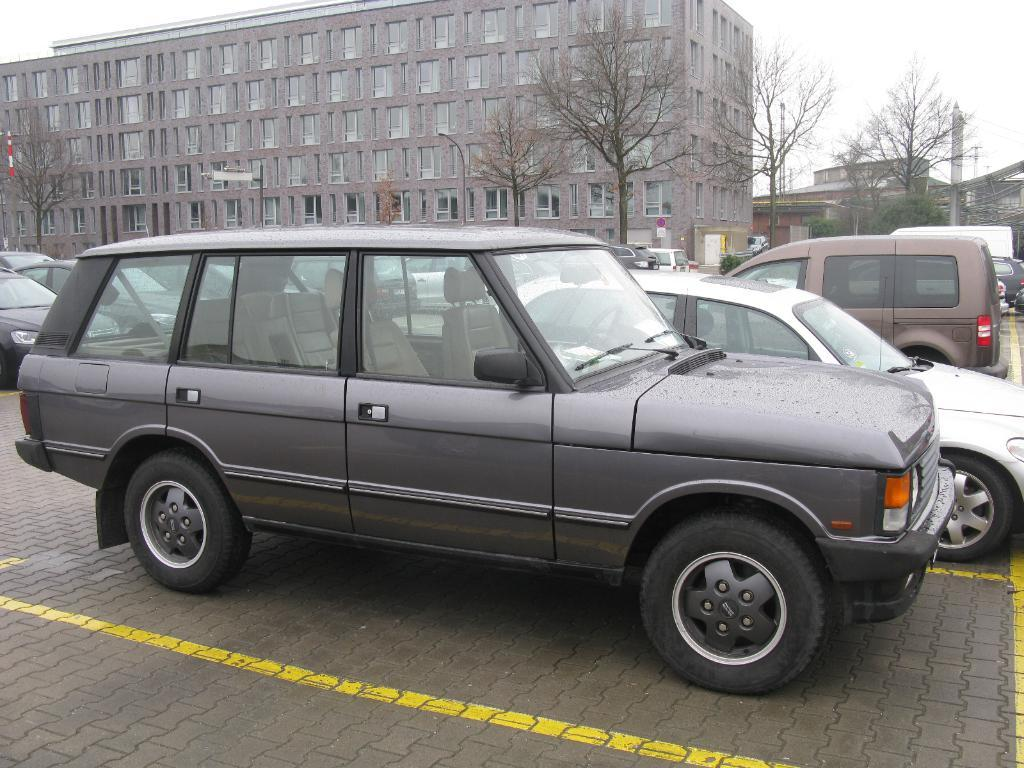What type of view is shown in the image? The image is an outside view. What can be seen on the road in the image? There are many cars on the road. What is visible in the background of the image? There are buildings and trees in the background. What is visible at the top of the image? The sky is visible at the top of the image. Can you see any balloons tied to the trees in the image? There are no balloons visible in the image; it only shows cars on the road, buildings, trees, and the sky. What type of lace can be seen hanging from the buildings in the image? There is no lace visible in the image; the buildings are solid structures with no decorative elements mentioned. 